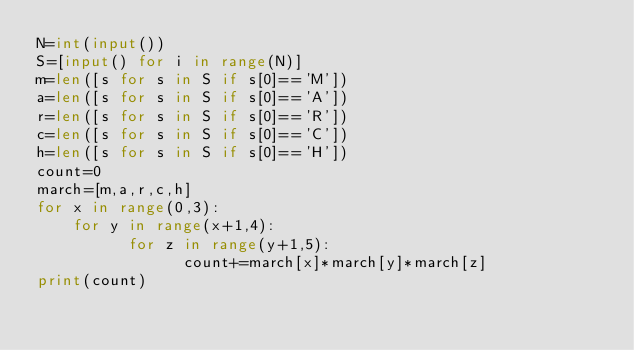Convert code to text. <code><loc_0><loc_0><loc_500><loc_500><_Python_>N=int(input())
S=[input() for i in range(N)]
m=len([s for s in S if s[0]=='M'])
a=len([s for s in S if s[0]=='A'])
r=len([s for s in S if s[0]=='R'])
c=len([s for s in S if s[0]=='C'])
h=len([s for s in S if s[0]=='H'])
count=0
march=[m,a,r,c,h]
for x in range(0,3):
    for y in range(x+1,4):
          for z in range(y+1,5):
                count+=march[x]*march[y]*march[z]
print(count)</code> 